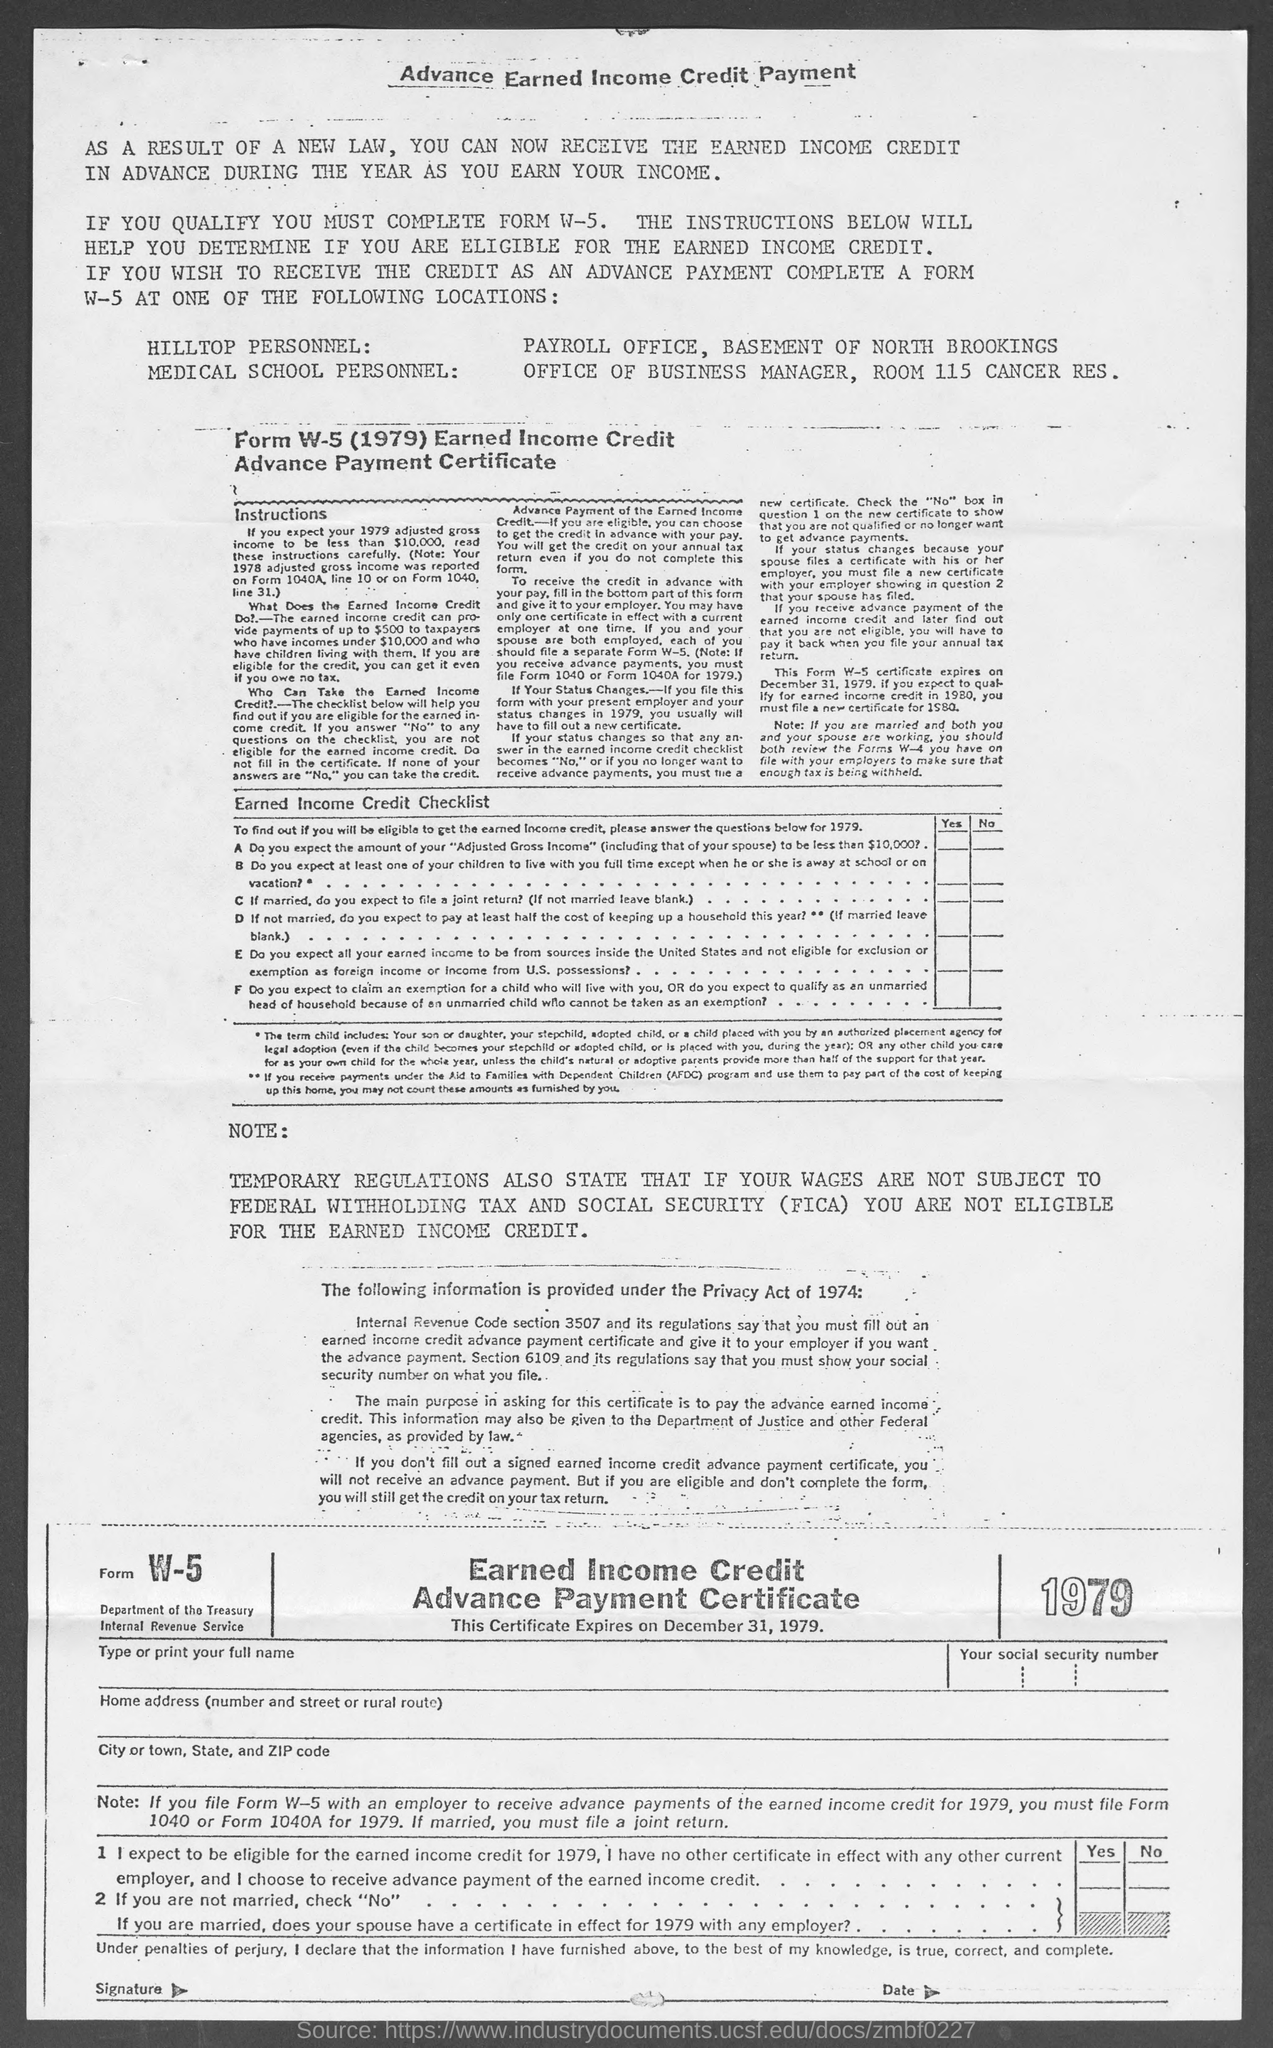Highlight a few significant elements in this photo. This certificate is set to expire on December 31, 1979. 